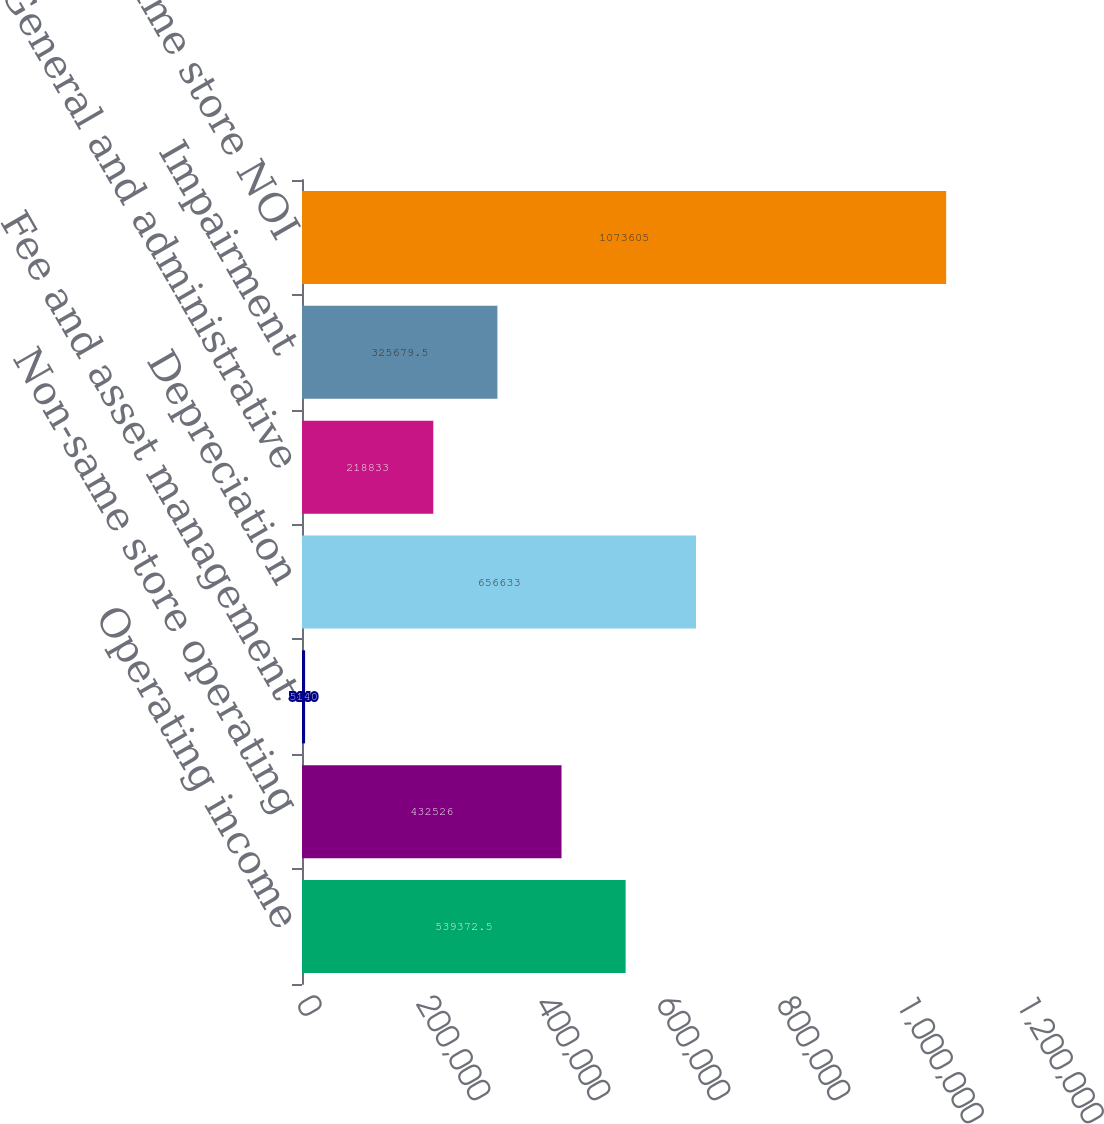Convert chart to OTSL. <chart><loc_0><loc_0><loc_500><loc_500><bar_chart><fcel>Operating income<fcel>Non-same store operating<fcel>Fee and asset management<fcel>Depreciation<fcel>General and administrative<fcel>Impairment<fcel>Same store NOI<nl><fcel>539372<fcel>432526<fcel>5140<fcel>656633<fcel>218833<fcel>325680<fcel>1.0736e+06<nl></chart> 